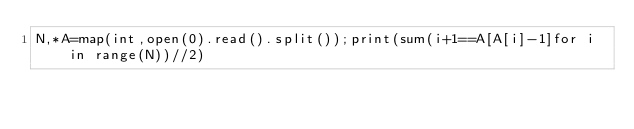<code> <loc_0><loc_0><loc_500><loc_500><_Python_>N,*A=map(int,open(0).read().split());print(sum(i+1==A[A[i]-1]for i in range(N))//2)</code> 